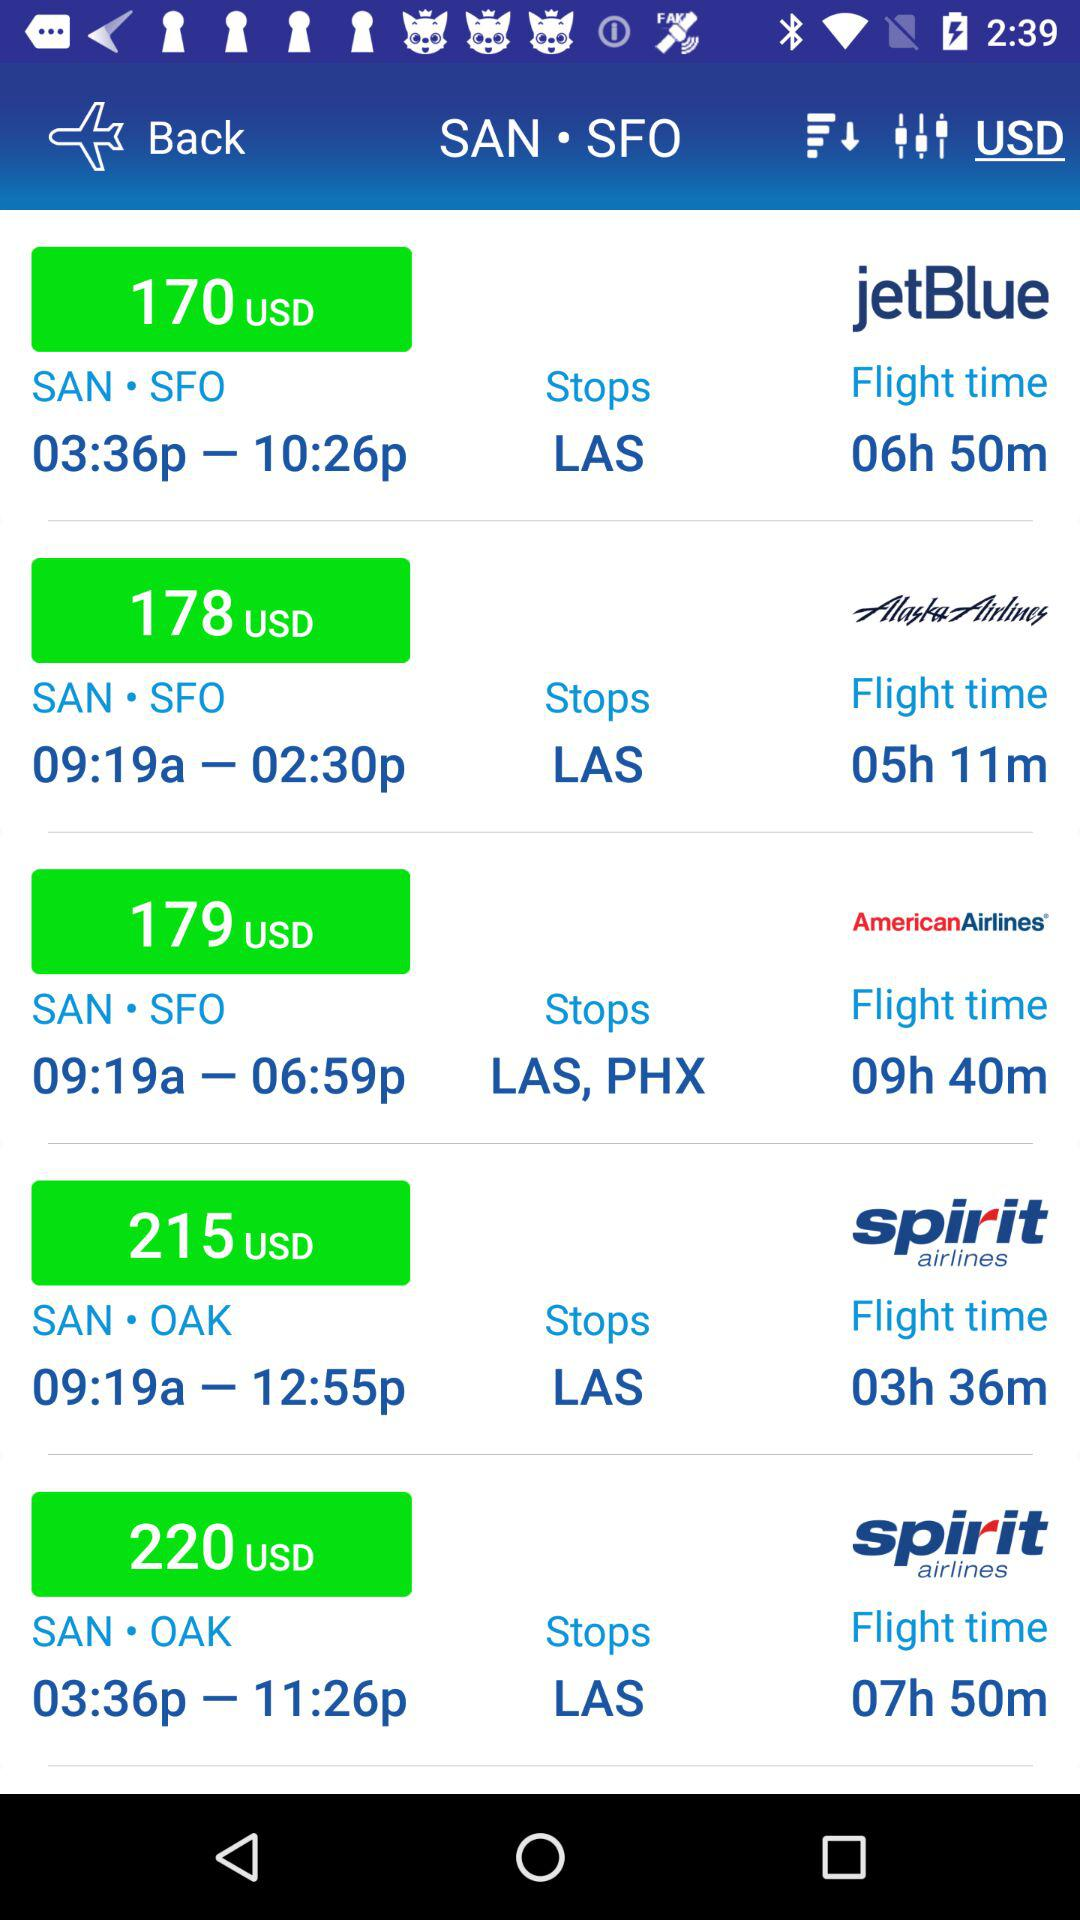What is the destination station? The destination stations are "SFO" and "OAK". 